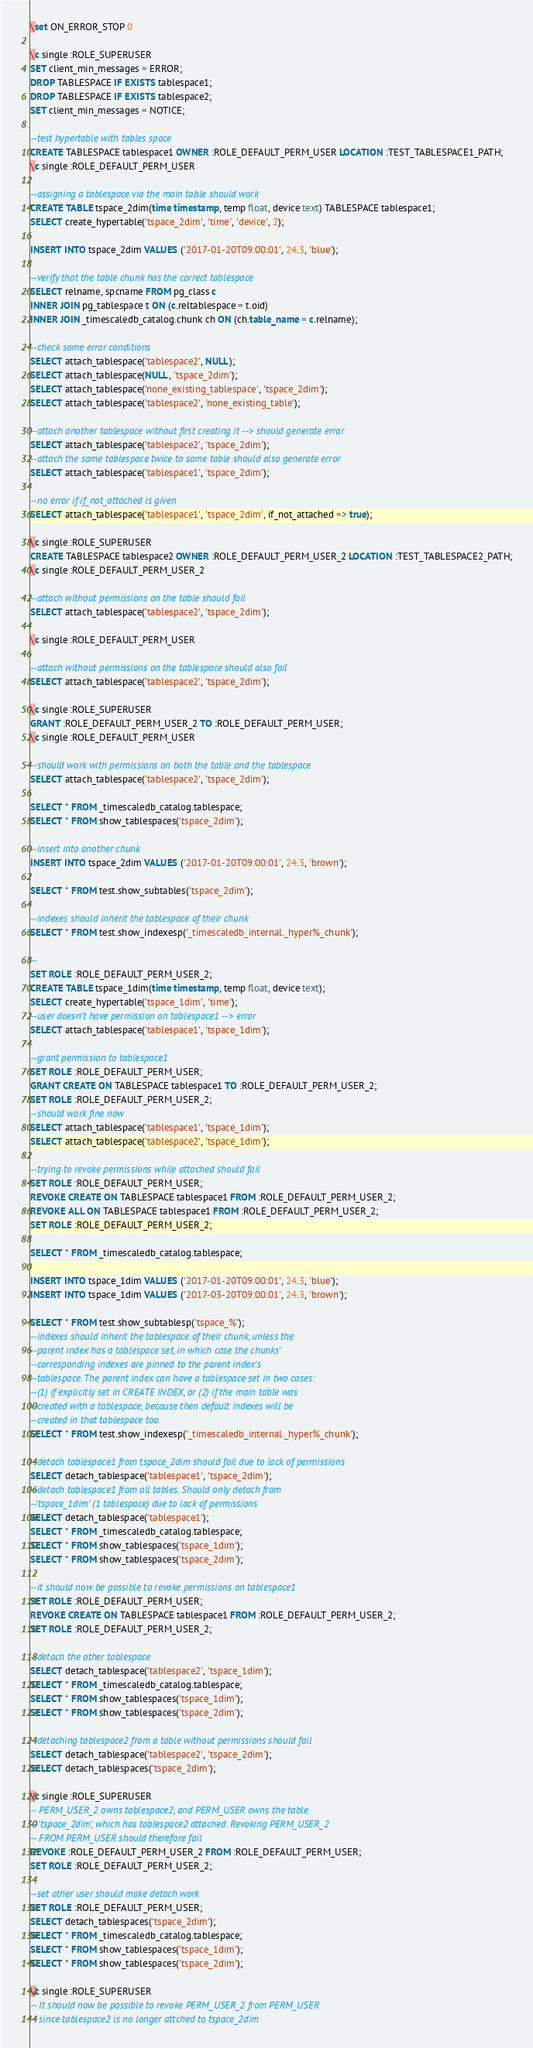Convert code to text. <code><loc_0><loc_0><loc_500><loc_500><_SQL_>\set ON_ERROR_STOP 0

\c single :ROLE_SUPERUSER
SET client_min_messages = ERROR;
DROP TABLESPACE IF EXISTS tablespace1;
DROP TABLESPACE IF EXISTS tablespace2;
SET client_min_messages = NOTICE;

--test hypertable with tables space
CREATE TABLESPACE tablespace1 OWNER :ROLE_DEFAULT_PERM_USER LOCATION :TEST_TABLESPACE1_PATH;
\c single :ROLE_DEFAULT_PERM_USER

--assigning a tablespace via the main table should work
CREATE TABLE tspace_2dim(time timestamp, temp float, device text) TABLESPACE tablespace1;
SELECT create_hypertable('tspace_2dim', 'time', 'device', 2);

INSERT INTO tspace_2dim VALUES ('2017-01-20T09:00:01', 24.3, 'blue');

--verify that the table chunk has the correct tablespace
SELECT relname, spcname FROM pg_class c
INNER JOIN pg_tablespace t ON (c.reltablespace = t.oid)
INNER JOIN _timescaledb_catalog.chunk ch ON (ch.table_name = c.relname);

--check some error conditions
SELECT attach_tablespace('tablespace2', NULL);
SELECT attach_tablespace(NULL, 'tspace_2dim');
SELECT attach_tablespace('none_existing_tablespace', 'tspace_2dim');
SELECT attach_tablespace('tablespace2', 'none_existing_table');

--attach another tablespace without first creating it --> should generate error
SELECT attach_tablespace('tablespace2', 'tspace_2dim');
--attach the same tablespace twice to same table should also generate error
SELECT attach_tablespace('tablespace1', 'tspace_2dim');

--no error if if_not_attached is given
SELECT attach_tablespace('tablespace1', 'tspace_2dim', if_not_attached => true);

\c single :ROLE_SUPERUSER
CREATE TABLESPACE tablespace2 OWNER :ROLE_DEFAULT_PERM_USER_2 LOCATION :TEST_TABLESPACE2_PATH;
\c single :ROLE_DEFAULT_PERM_USER_2

--attach without permissions on the table should fail
SELECT attach_tablespace('tablespace2', 'tspace_2dim');

\c single :ROLE_DEFAULT_PERM_USER

--attach without permissions on the tablespace should also fail
SELECT attach_tablespace('tablespace2', 'tspace_2dim');

\c single :ROLE_SUPERUSER
GRANT :ROLE_DEFAULT_PERM_USER_2 TO :ROLE_DEFAULT_PERM_USER;
\c single :ROLE_DEFAULT_PERM_USER

--should work with permissions on both the table and the tablespace
SELECT attach_tablespace('tablespace2', 'tspace_2dim');

SELECT * FROM _timescaledb_catalog.tablespace;
SELECT * FROM show_tablespaces('tspace_2dim');

--insert into another chunk
INSERT INTO tspace_2dim VALUES ('2017-01-20T09:00:01', 24.3, 'brown');

SELECT * FROM test.show_subtables('tspace_2dim');

--indexes should inherit the tablespace of their chunk
SELECT * FROM test.show_indexesp('_timescaledb_internal._hyper%_chunk');

--
SET ROLE :ROLE_DEFAULT_PERM_USER_2;
CREATE TABLE tspace_1dim(time timestamp, temp float, device text);
SELECT create_hypertable('tspace_1dim', 'time');
--user doesn't have permission on tablespace1 --> error
SELECT attach_tablespace('tablespace1', 'tspace_1dim');

--grant permission to tablespace1
SET ROLE :ROLE_DEFAULT_PERM_USER;
GRANT CREATE ON TABLESPACE tablespace1 TO :ROLE_DEFAULT_PERM_USER_2;
SET ROLE :ROLE_DEFAULT_PERM_USER_2;
--should work fine now
SELECT attach_tablespace('tablespace1', 'tspace_1dim');
SELECT attach_tablespace('tablespace2', 'tspace_1dim');

--trying to revoke permissions while attached should fail
SET ROLE :ROLE_DEFAULT_PERM_USER;
REVOKE CREATE ON TABLESPACE tablespace1 FROM :ROLE_DEFAULT_PERM_USER_2;
REVOKE ALL ON TABLESPACE tablespace1 FROM :ROLE_DEFAULT_PERM_USER_2;
SET ROLE :ROLE_DEFAULT_PERM_USER_2;

SELECT * FROM _timescaledb_catalog.tablespace;

INSERT INTO tspace_1dim VALUES ('2017-01-20T09:00:01', 24.3, 'blue');
INSERT INTO tspace_1dim VALUES ('2017-03-20T09:00:01', 24.3, 'brown');

SELECT * FROM test.show_subtablesp('tspace_%');
--indexes should inherit the tablespace of their chunk, unless the
--parent index has a tablespace set, in which case the chunks'
--corresponding indexes are pinned to the parent index's
--tablespace. The parent index can have a tablespace set in two cases:
--(1) if explicitly set in CREATE INDEX, or (2) if the main table was
--created with a tablespace, because then default indexes will be
--created in that tablespace too.
SELECT * FROM test.show_indexesp('_timescaledb_internal._hyper%_chunk');

--detach tablespace1 from tspace_2dim should fail due to lack of permissions
SELECT detach_tablespace('tablespace1', 'tspace_2dim');
--detach tablespace1 from all tables. Should only detach from
--'tspace_1dim' (1 tablespace) due to lack of permissions
SELECT detach_tablespace('tablespace1');
SELECT * FROM _timescaledb_catalog.tablespace;
SELECT * FROM show_tablespaces('tspace_1dim');
SELECT * FROM show_tablespaces('tspace_2dim');

--it should now be possible to revoke permissions on tablespace1
SET ROLE :ROLE_DEFAULT_PERM_USER;
REVOKE CREATE ON TABLESPACE tablespace1 FROM :ROLE_DEFAULT_PERM_USER_2;
SET ROLE :ROLE_DEFAULT_PERM_USER_2;

--detach the other tablespace
SELECT detach_tablespace('tablespace2', 'tspace_1dim');
SELECT * FROM _timescaledb_catalog.tablespace;
SELECT * FROM show_tablespaces('tspace_1dim');
SELECT * FROM show_tablespaces('tspace_2dim');

--detaching tablespace2 from a table without permissions should fail
SELECT detach_tablespace('tablespace2', 'tspace_2dim');
SELECT detach_tablespaces('tspace_2dim');

\c single :ROLE_SUPERUSER
-- PERM_USER_2 owns tablespace2, and PERM_USER owns the table
-- 'tspace_2dim', which has tablespace2 attached. Revoking PERM_USER_2
-- FROM PERM_USER should therefore fail
REVOKE :ROLE_DEFAULT_PERM_USER_2 FROM :ROLE_DEFAULT_PERM_USER;
SET ROLE :ROLE_DEFAULT_PERM_USER_2;

--set other user should make detach work
SET ROLE :ROLE_DEFAULT_PERM_USER;
SELECT detach_tablespaces('tspace_2dim');
SELECT * FROM _timescaledb_catalog.tablespace;
SELECT * FROM show_tablespaces('tspace_1dim');
SELECT * FROM show_tablespaces('tspace_2dim');

\c single :ROLE_SUPERUSER
-- It should now be possible to revoke PERM_USER_2 from PERM_USER
-- since tablespace2 is no longer attched to tspace_2dim</code> 